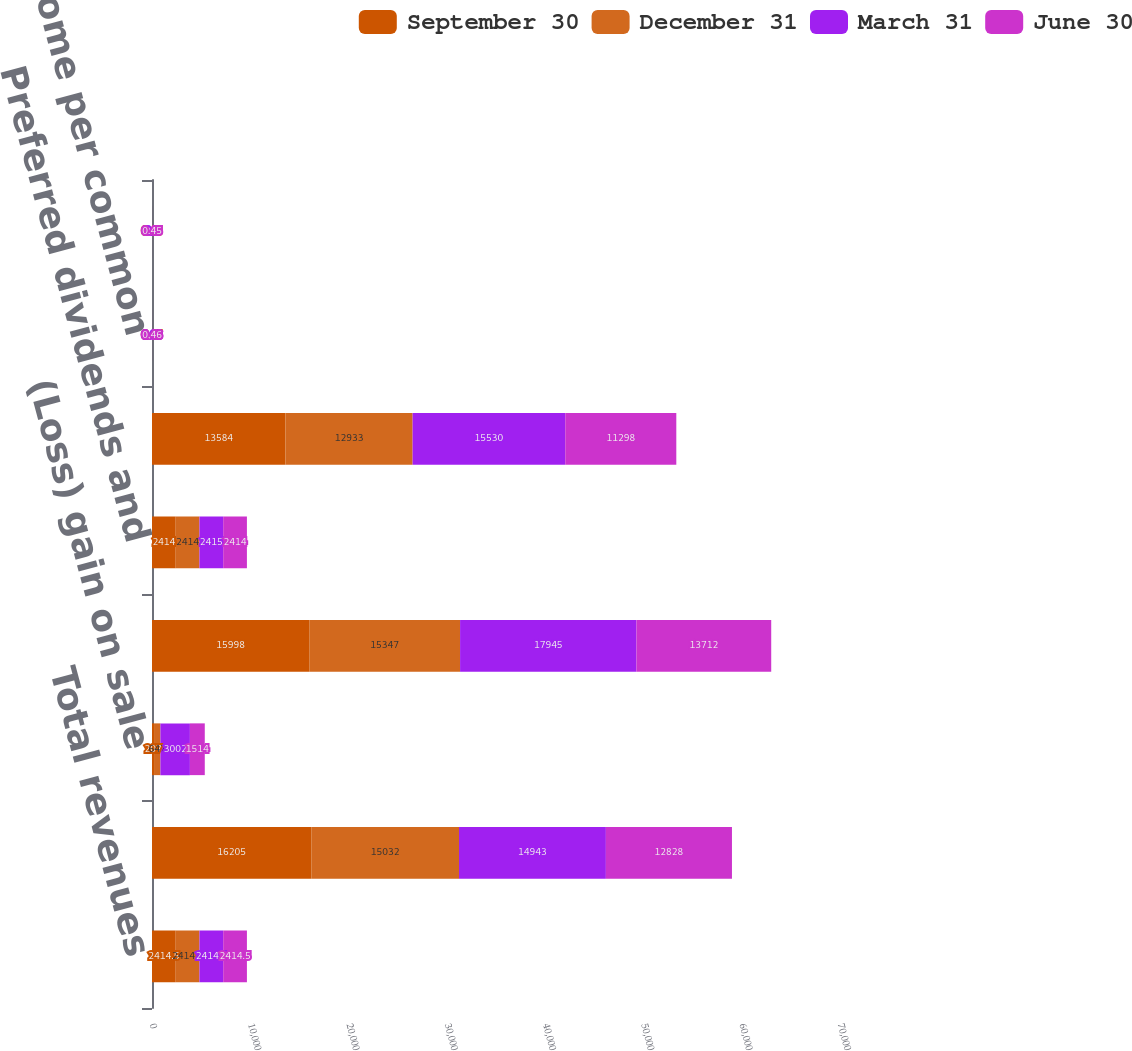<chart> <loc_0><loc_0><loc_500><loc_500><stacked_bar_chart><ecel><fcel>Total revenues<fcel>Income net of minority<fcel>(Loss) gain on sale<fcel>Net income before preferred<fcel>Preferred dividends and<fcel>Income available to common<fcel>Net income per common<fcel>-Diluted<nl><fcel>September 30<fcel>2414.5<fcel>16205<fcel>207<fcel>15998<fcel>2414<fcel>13584<fcel>0.45<fcel>0.45<nl><fcel>December 31<fcel>2414.5<fcel>15032<fcel>647<fcel>15347<fcel>2414<fcel>12933<fcel>0.45<fcel>0.44<nl><fcel>March 31<fcel>2414.5<fcel>14943<fcel>3002<fcel>17945<fcel>2415<fcel>15530<fcel>0.63<fcel>0.6<nl><fcel>June 30<fcel>2414.5<fcel>12828<fcel>1514<fcel>13712<fcel>2414<fcel>11298<fcel>0.46<fcel>0.45<nl></chart> 